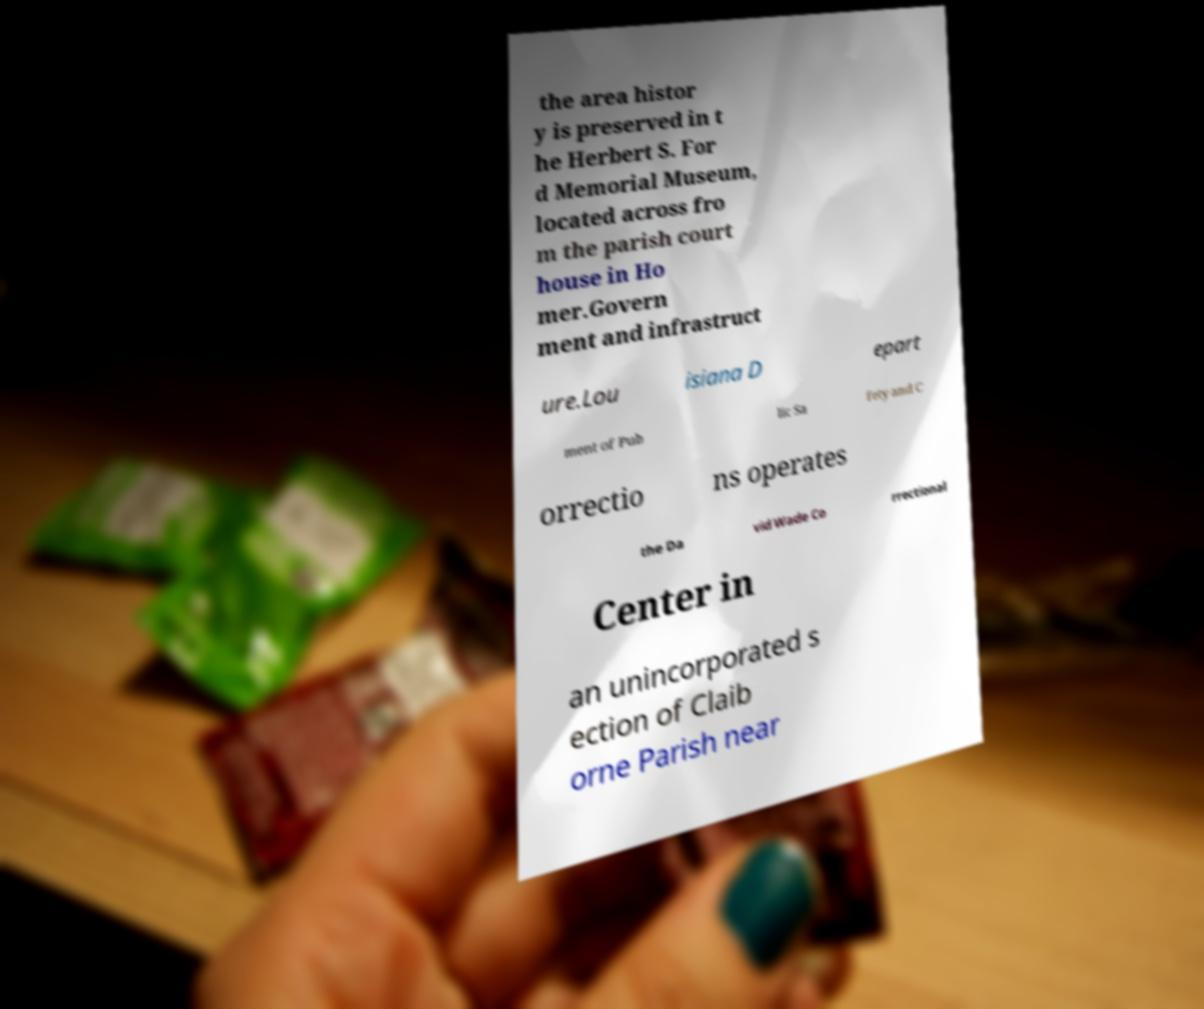Can you read and provide the text displayed in the image?This photo seems to have some interesting text. Can you extract and type it out for me? the area histor y is preserved in t he Herbert S. For d Memorial Museum, located across fro m the parish court house in Ho mer.Govern ment and infrastruct ure.Lou isiana D epart ment of Pub lic Sa fety and C orrectio ns operates the Da vid Wade Co rrectional Center in an unincorporated s ection of Claib orne Parish near 